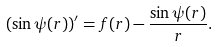Convert formula to latex. <formula><loc_0><loc_0><loc_500><loc_500>( \sin \psi ( r ) ) ^ { \prime } = f ( r ) - \frac { \sin \psi ( r ) } { r } .</formula> 